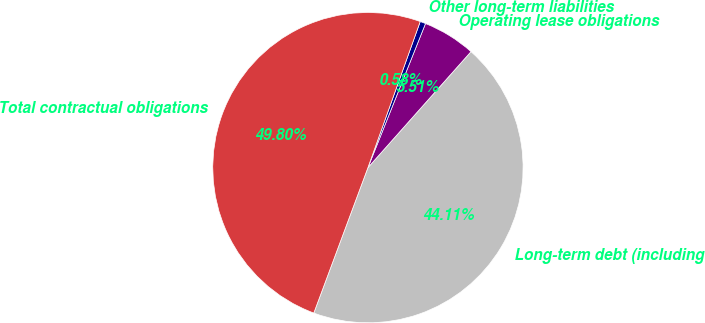<chart> <loc_0><loc_0><loc_500><loc_500><pie_chart><fcel>Long-term debt (including<fcel>Operating lease obligations<fcel>Other long-term liabilities<fcel>Total contractual obligations<nl><fcel>44.11%<fcel>5.51%<fcel>0.58%<fcel>49.8%<nl></chart> 